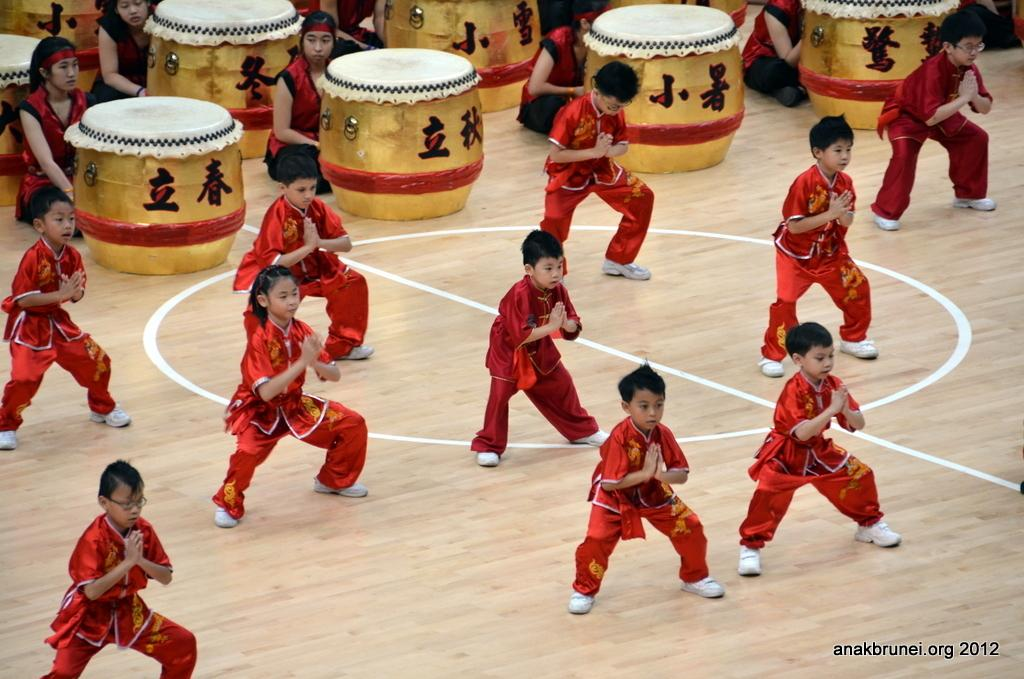What is the main subject of the image? The main subject of the image is a group of children. What are the children doing in the image? The children are standing in the image. Are there any other people in the image besides the children? Yes, there are persons sitting behind musical instruments in the image. What type of trains can be seen in the background of the image? There are no trains visible in the image; it features a group of children standing and persons sitting behind musical instruments. Can you tell me how many times the camera has been used to take this picture? The image does not provide information about the number of times the camera has been used to take the picture. 